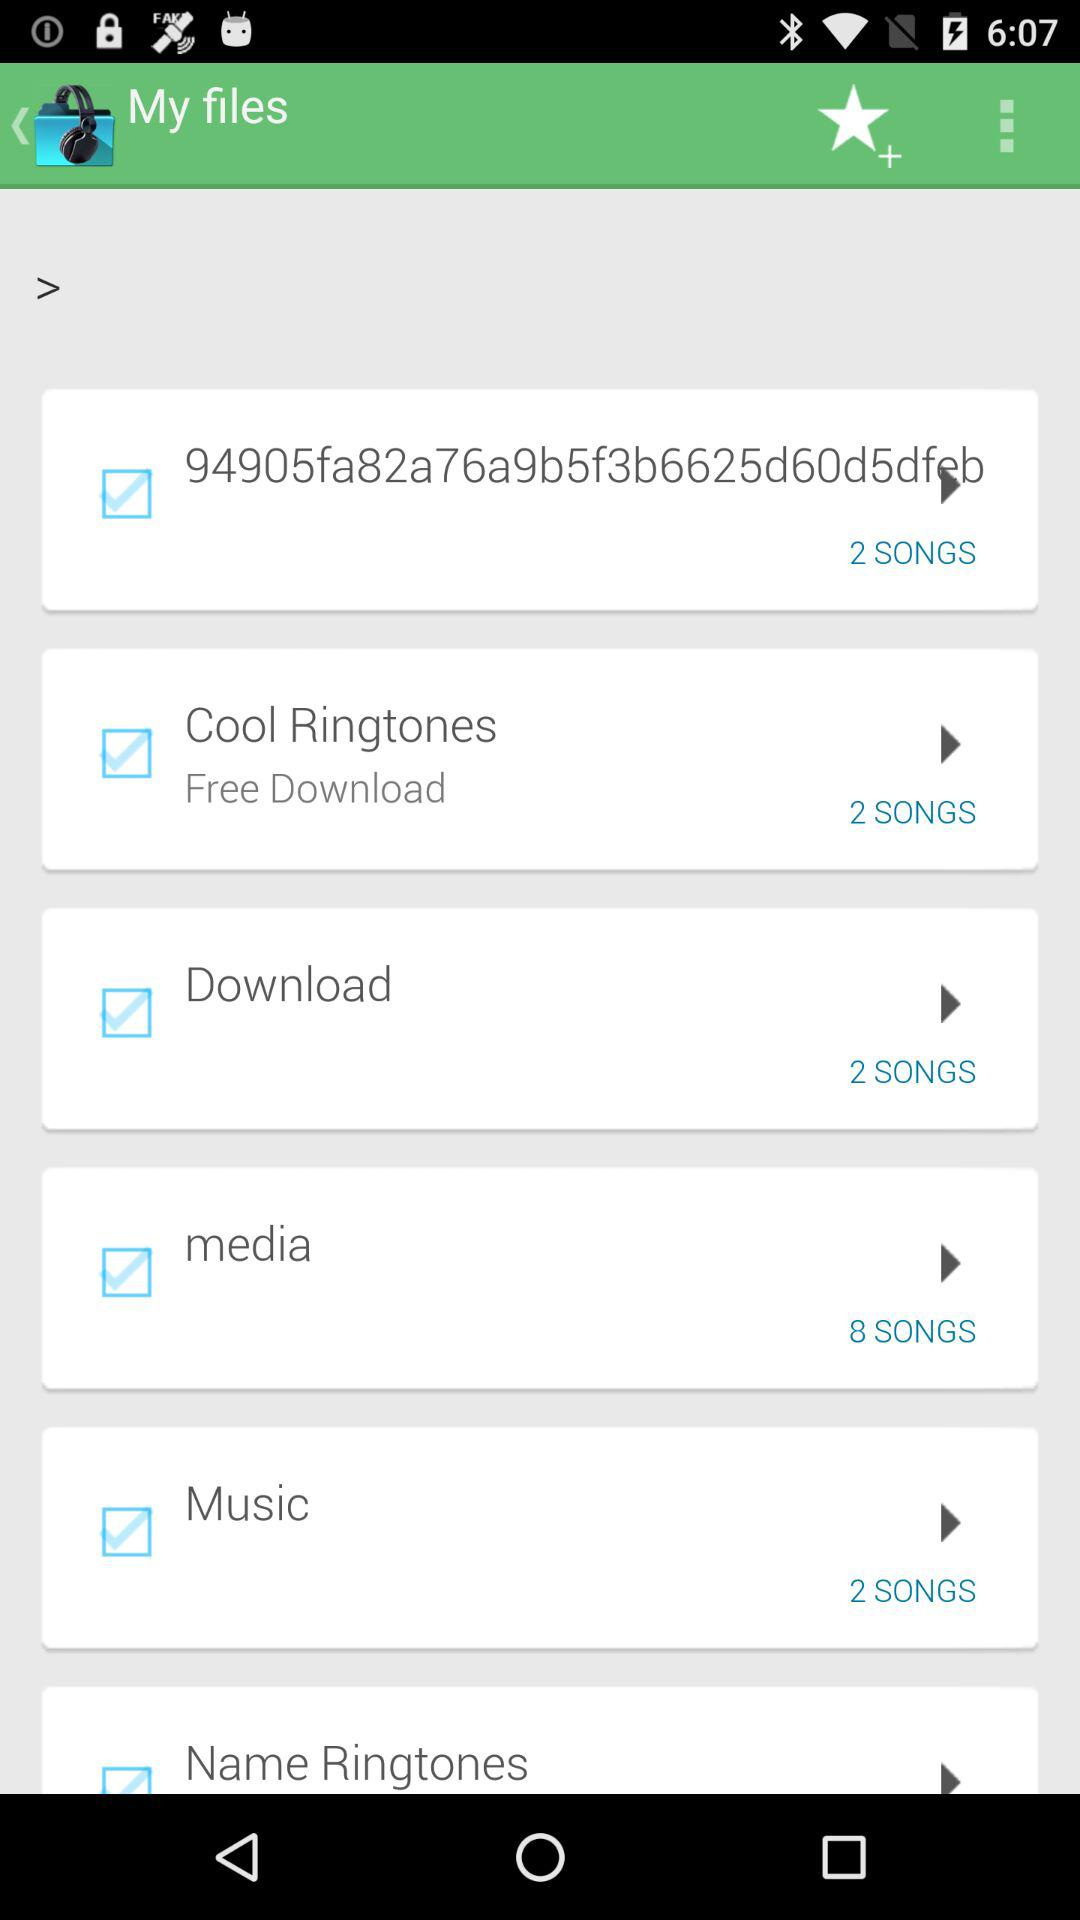How many songs are there in the "Download" file? There are 2 songs in the "Download" file. 